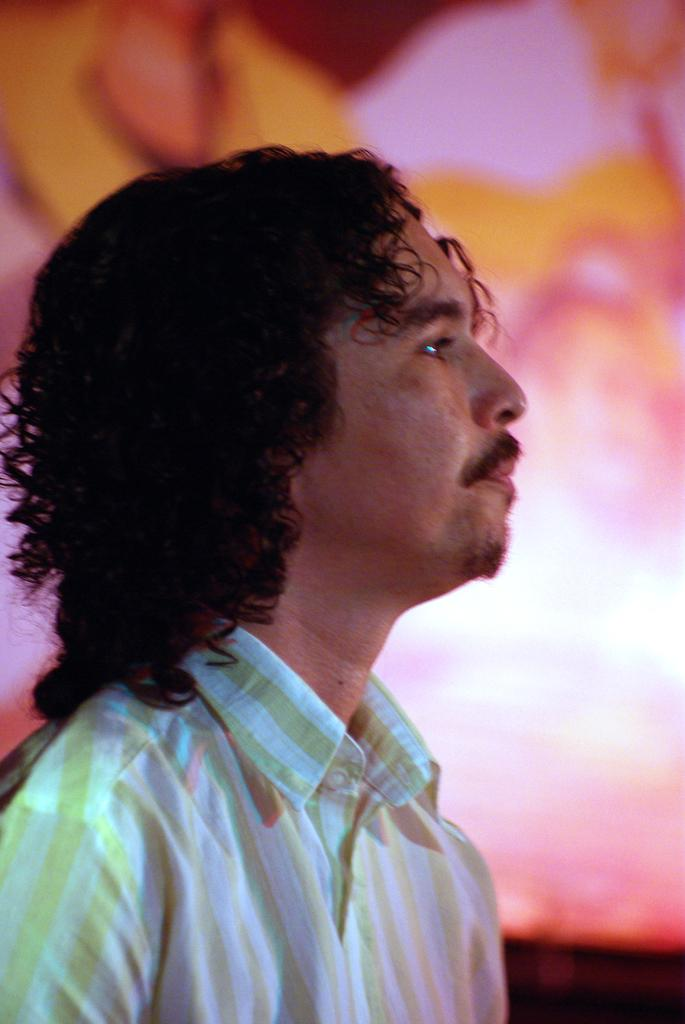What is the main subject of the image? There is a person in the image. Can you describe the person's attire? The person is wearing clothes. What is the condition of the background in the image? The background of the image is blurred. What type of vein can be seen on the person's arm in the image? There is no visible vein on the person's arm in the image. Is the person's brother also present in the image? There is no information about the person's brother in the image. 